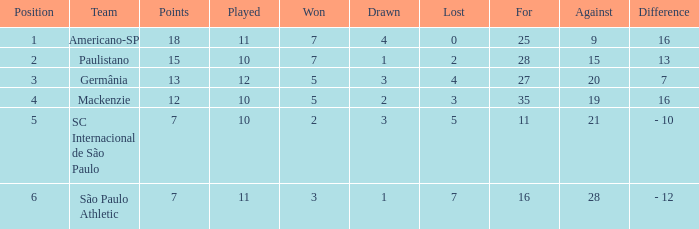What is the greatest number when the difference between two numbers is 7? 27.0. 